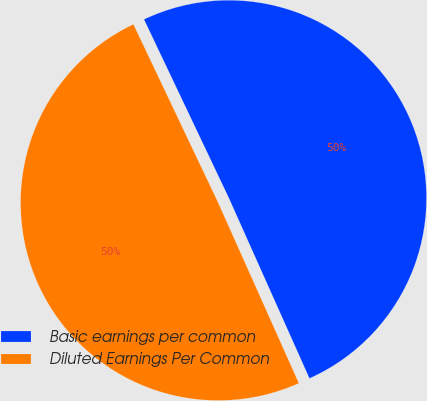Convert chart. <chart><loc_0><loc_0><loc_500><loc_500><pie_chart><fcel>Basic earnings per common<fcel>Diluted Earnings Per Common<nl><fcel>50.37%<fcel>49.63%<nl></chart> 